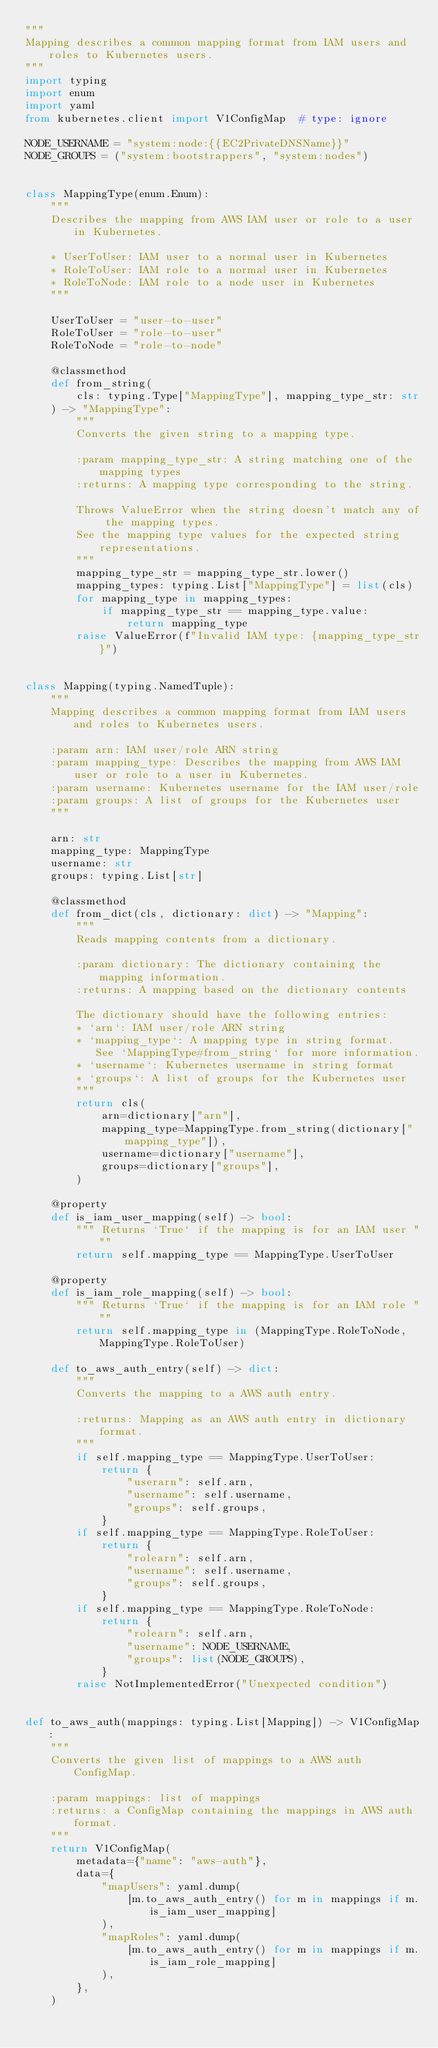Convert code to text. <code><loc_0><loc_0><loc_500><loc_500><_Python_>"""
Mapping describes a common mapping format from IAM users and roles to Kubernetes users.
"""
import typing
import enum
import yaml
from kubernetes.client import V1ConfigMap  # type: ignore

NODE_USERNAME = "system:node:{{EC2PrivateDNSName}}"
NODE_GROUPS = ("system:bootstrappers", "system:nodes")


class MappingType(enum.Enum):
    """
    Describes the mapping from AWS IAM user or role to a user in Kubernetes.

    * UserToUser: IAM user to a normal user in Kubernetes
    * RoleToUser: IAM role to a normal user in Kubernetes
    * RoleToNode: IAM role to a node user in Kubernetes
    """

    UserToUser = "user-to-user"
    RoleToUser = "role-to-user"
    RoleToNode = "role-to-node"

    @classmethod
    def from_string(
        cls: typing.Type["MappingType"], mapping_type_str: str
    ) -> "MappingType":
        """
        Converts the given string to a mapping type.

        :param mapping_type_str: A string matching one of the mapping types
        :returns: A mapping type corresponding to the string.

        Throws ValueError when the string doesn't match any of the mapping types.
        See the mapping type values for the expected string representations.
        """
        mapping_type_str = mapping_type_str.lower()
        mapping_types: typing.List["MappingType"] = list(cls)
        for mapping_type in mapping_types:
            if mapping_type_str == mapping_type.value:
                return mapping_type
        raise ValueError(f"Invalid IAM type: {mapping_type_str}")


class Mapping(typing.NamedTuple):
    """
    Mapping describes a common mapping format from IAM users and roles to Kubernetes users.

    :param arn: IAM user/role ARN string
    :param mapping_type: Describes the mapping from AWS IAM user or role to a user in Kubernetes.
    :param username: Kubernetes username for the IAM user/role
    :param groups: A list of groups for the Kubernetes user
    """

    arn: str
    mapping_type: MappingType
    username: str
    groups: typing.List[str]

    @classmethod
    def from_dict(cls, dictionary: dict) -> "Mapping":
        """
        Reads mapping contents from a dictionary.

        :param dictionary: The dictionary containing the mapping information.
        :returns: A mapping based on the dictionary contents

        The dictionary should have the following entries:
        * `arn`: IAM user/role ARN string
        * `mapping_type`: A mapping type in string format.
           See `MappingType#from_string` for more information.
        * `username`: Kubernetes username in string format
        * `groups`: A list of groups for the Kubernetes user
        """
        return cls(
            arn=dictionary["arn"],
            mapping_type=MappingType.from_string(dictionary["mapping_type"]),
            username=dictionary["username"],
            groups=dictionary["groups"],
        )

    @property
    def is_iam_user_mapping(self) -> bool:
        """ Returns `True` if the mapping is for an IAM user """
        return self.mapping_type == MappingType.UserToUser

    @property
    def is_iam_role_mapping(self) -> bool:
        """ Returns `True` if the mapping is for an IAM role """
        return self.mapping_type in (MappingType.RoleToNode, MappingType.RoleToUser)

    def to_aws_auth_entry(self) -> dict:
        """
        Converts the mapping to a AWS auth entry.

        :returns: Mapping as an AWS auth entry in dictionary format.
        """
        if self.mapping_type == MappingType.UserToUser:
            return {
                "userarn": self.arn,
                "username": self.username,
                "groups": self.groups,
            }
        if self.mapping_type == MappingType.RoleToUser:
            return {
                "rolearn": self.arn,
                "username": self.username,
                "groups": self.groups,
            }
        if self.mapping_type == MappingType.RoleToNode:
            return {
                "rolearn": self.arn,
                "username": NODE_USERNAME,
                "groups": list(NODE_GROUPS),
            }
        raise NotImplementedError("Unexpected condition")


def to_aws_auth(mappings: typing.List[Mapping]) -> V1ConfigMap:
    """
    Converts the given list of mappings to a AWS auth ConfigMap.

    :param mappings: list of mappings
    :returns: a ConfigMap containing the mappings in AWS auth format.
    """
    return V1ConfigMap(
        metadata={"name": "aws-auth"},
        data={
            "mapUsers": yaml.dump(
                [m.to_aws_auth_entry() for m in mappings if m.is_iam_user_mapping]
            ),
            "mapRoles": yaml.dump(
                [m.to_aws_auth_entry() for m in mappings if m.is_iam_role_mapping]
            ),
        },
    )
</code> 